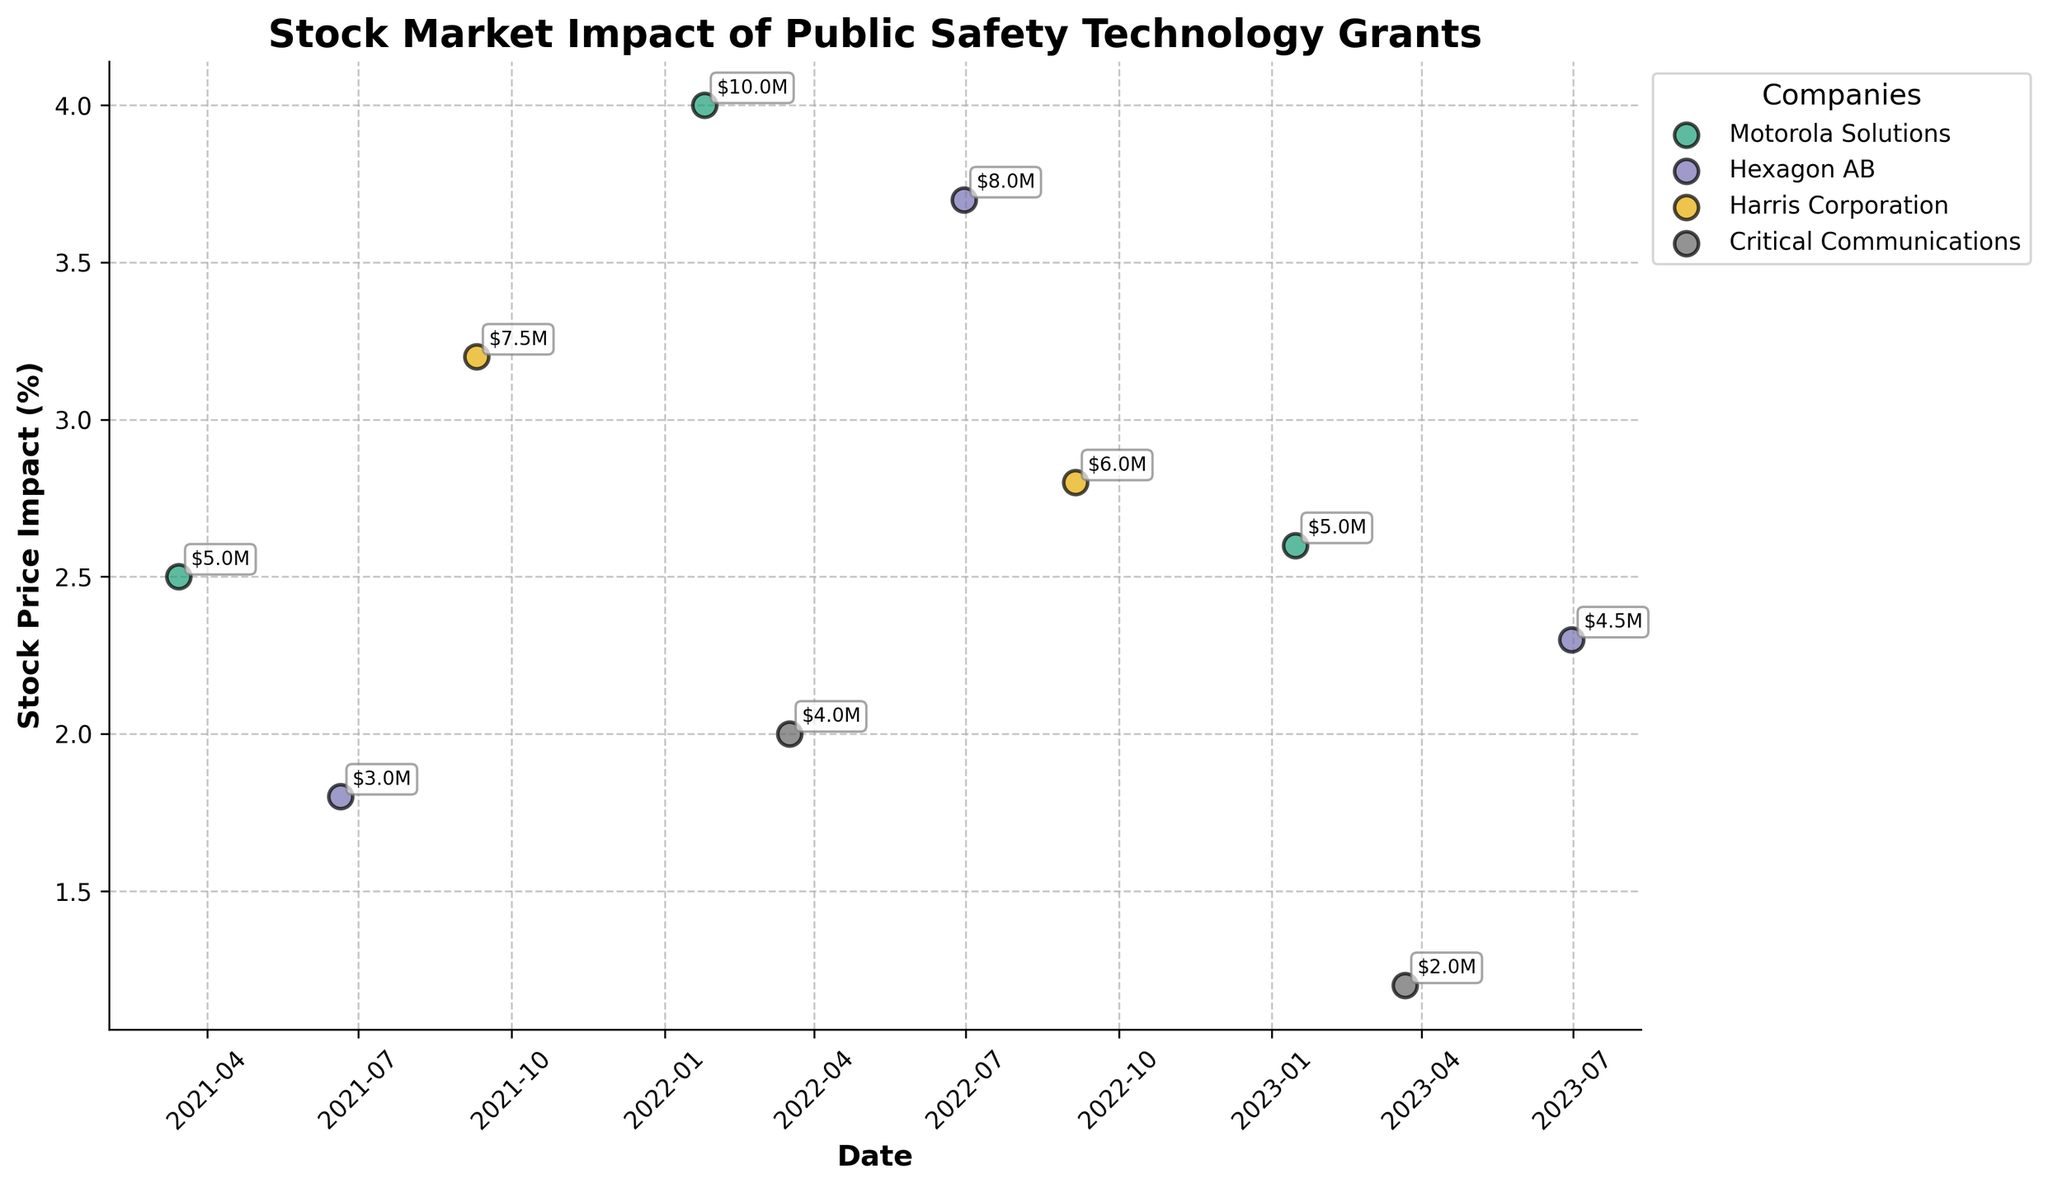What is the title of the plot? The title of the plot is written at the top of the figure.
Answer: Stock Market Impact of Public Safety Technology Grants How many companies are displayed in the figure? Each different color represents a different company. By counting the distinct colors in the legend, you can determine the number of companies.
Answer: 4 Which company had the highest stock price impact from a grant received? Look at the scatter plot points and find the highest stock price impact value associated with the "Grant Received" label and note the corresponding company.
Answer: Harris Corporation On which date did Hexagon AB receive the highest stock price impact, and what was the value? Identify the highest stock price impact marker for Hexagon AB and then check the corresponding date and value on the axes.
Answer: 2022-06-30, 3.7% What’s the average stock price impact for Motorola Solutions on the dates provided? Find all stock price impacts for Motorola Solutions, add them up, and then divide by the number of occurrences.
Answer: (2.5 + 4.0 + 2.6) / 3 = 3.0% Compare the stock price impact of Motorola Solutions when they secured funding on 2022-01-25 to any of the grants they received. Was it higher? Look for the stock price impact value on 2022-01-25 and compare it to the stock price impacts of grants received by Motorola Solutions.
Answer: Yes, it was higher Which event type (Grant Received or Funding Secured) appears to have a higher average stock price impact for Hexagon AB? Calculate the average stock price impact for each event type for Hexagon AB: add all values under each event type and divide by their respective counts.
Answer: Funding Secured Which company secured funding with the lowest stock price impact, and what was the value? Identify the lowest stock price impact among the 'Funding Secured' events by checking the scatter plot points and the annotations for respective values.
Answer: Critical Communications, 1.2% How many events in total for Harris Corporation are plotted, and what are their respective dates? Count the number of data points for Harris Corporation in the plot and list their dates.
Answer: 2 events; 2021-09-10 and 2022-09-05 Is Hexagon AB's stock price impact higher on average for funding secured or grants received? Calculate and compare the average stock price impacts for both "Funding Secured" and "Grant Received" types for Hexagon AB by summing and dividing by the number of entries.
Answer: Funding Secured 